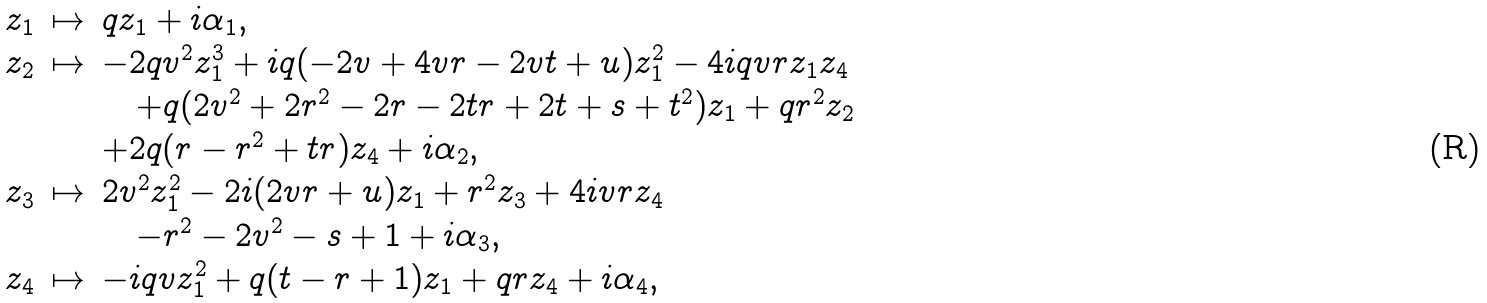Convert formula to latex. <formula><loc_0><loc_0><loc_500><loc_500>\begin{array} { l l l } z _ { 1 } & \mapsto & q z _ { 1 } + i \alpha _ { 1 } , \\ z _ { 2 } & \mapsto & - 2 q v ^ { 2 } z _ { 1 } ^ { 3 } + i q ( - 2 v + 4 v r - 2 v t + u ) z _ { 1 } ^ { 2 } - 4 i q v r z _ { 1 } z _ { 4 } \\ & & \quad + q ( 2 v ^ { 2 } + 2 r ^ { 2 } - 2 r - 2 t r + 2 t + s + t ^ { 2 } ) z _ { 1 } + q r ^ { 2 } z _ { 2 } \\ & & + 2 q ( r - r ^ { 2 } + t r ) z _ { 4 } + i \alpha _ { 2 } , \\ z _ { 3 } & \mapsto & 2 v ^ { 2 } z _ { 1 } ^ { 2 } - 2 i ( 2 v r + u ) z _ { 1 } + r ^ { 2 } z _ { 3 } + 4 i v r z _ { 4 } \\ & & \quad - r ^ { 2 } - 2 v ^ { 2 } - s + 1 + i \alpha _ { 3 } , \\ z _ { 4 } & \mapsto & - i q v z _ { 1 } ^ { 2 } + q ( t - r + 1 ) z _ { 1 } + q r z _ { 4 } + i \alpha _ { 4 } , \end{array}</formula> 